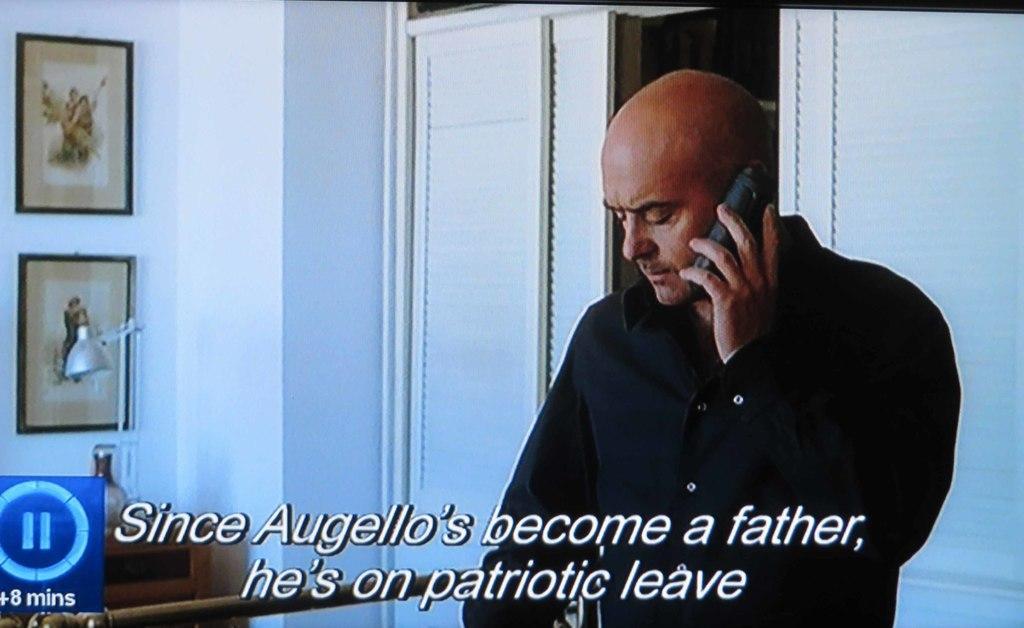Can you describe this image briefly? In this image I can see a person wearing black color dress and holding a mobile. Background I can see few frames attached to the wall, a table light and the wall is in white color. 